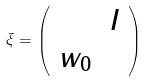<formula> <loc_0><loc_0><loc_500><loc_500>\xi = \left ( \begin{array} { c c } & I \\ w _ { 0 } & \end{array} \right )</formula> 